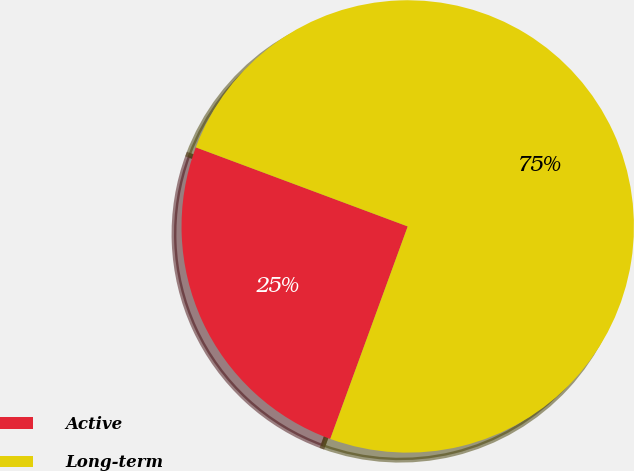<chart> <loc_0><loc_0><loc_500><loc_500><pie_chart><fcel>Active<fcel>Long-term<nl><fcel>25.12%<fcel>74.88%<nl></chart> 